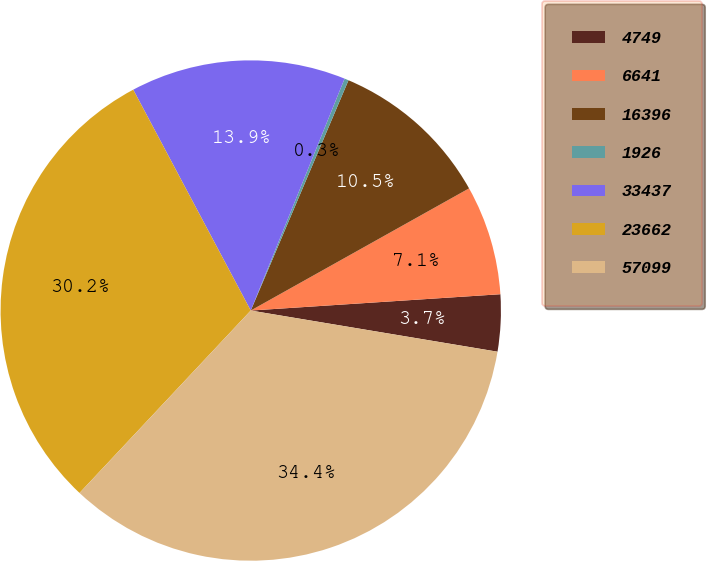Convert chart. <chart><loc_0><loc_0><loc_500><loc_500><pie_chart><fcel>4749<fcel>6641<fcel>16396<fcel>1926<fcel>33437<fcel>23662<fcel>57099<nl><fcel>3.67%<fcel>7.08%<fcel>10.49%<fcel>0.27%<fcel>13.9%<fcel>30.22%<fcel>34.36%<nl></chart> 